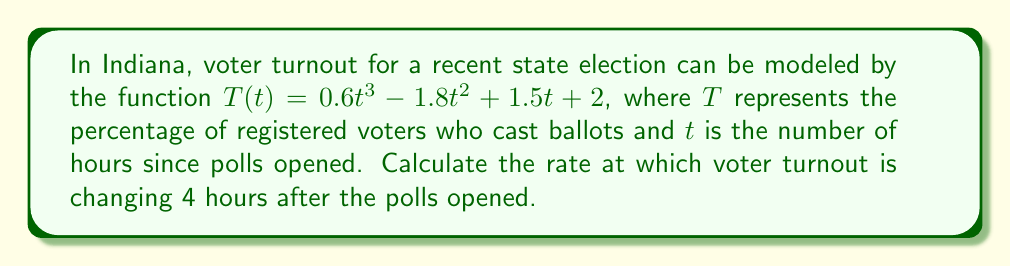Can you answer this question? To find the rate of change in voter turnout at a specific time, we need to calculate the derivative of the function $T(t)$ and then evaluate it at $t = 4$.

Step 1: Calculate the derivative of $T(t)$
$$\frac{d}{dt}T(t) = \frac{d}{dt}(0.6t^3 - 1.8t^2 + 1.5t + 2)$$
$$T'(t) = 1.8t^2 - 3.6t + 1.5$$

Step 2: Evaluate $T'(t)$ at $t = 4$
$$T'(4) = 1.8(4)^2 - 3.6(4) + 1.5$$
$$T'(4) = 1.8(16) - 14.4 + 1.5$$
$$T'(4) = 28.8 - 14.4 + 1.5$$
$$T'(4) = 15.9$$

The rate of change is measured in percentage points per hour, so our final answer is 15.9 percentage points per hour.
Answer: 15.9 percentage points per hour 